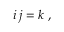Convert formula to latex. <formula><loc_0><loc_0><loc_500><loc_500>\, i \, j = k \, ,</formula> 